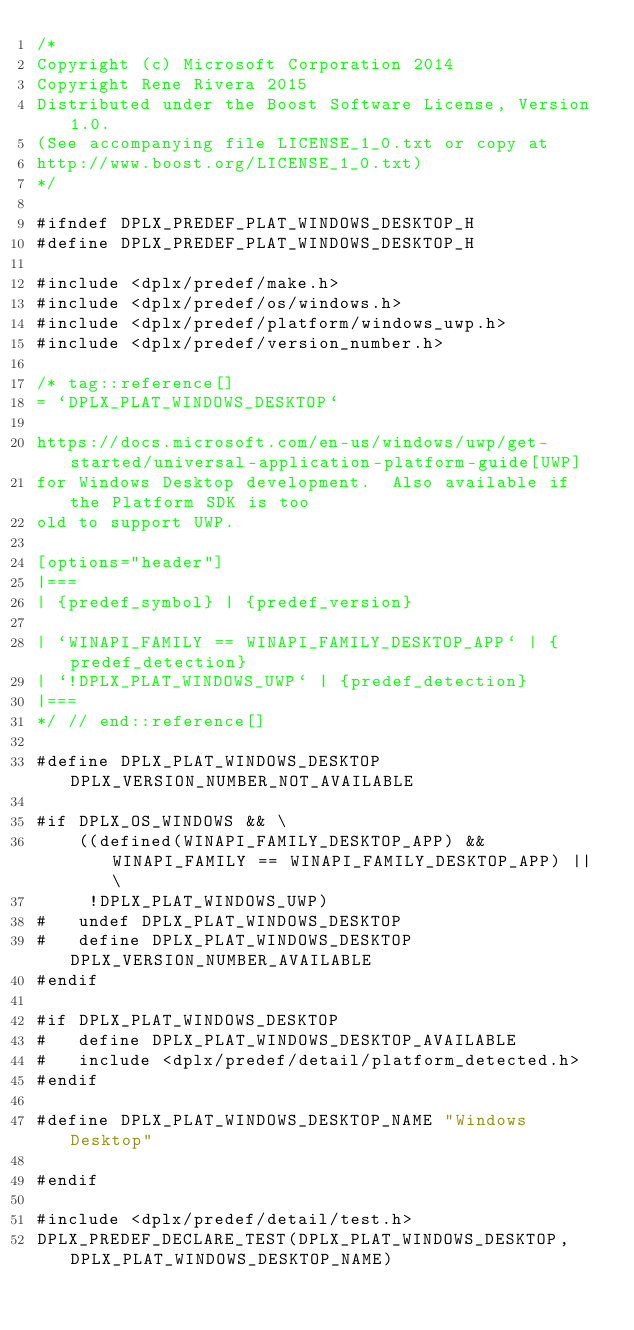<code> <loc_0><loc_0><loc_500><loc_500><_C_>/*
Copyright (c) Microsoft Corporation 2014
Copyright Rene Rivera 2015
Distributed under the Boost Software License, Version 1.0.
(See accompanying file LICENSE_1_0.txt or copy at
http://www.boost.org/LICENSE_1_0.txt)
*/

#ifndef DPLX_PREDEF_PLAT_WINDOWS_DESKTOP_H
#define DPLX_PREDEF_PLAT_WINDOWS_DESKTOP_H

#include <dplx/predef/make.h>
#include <dplx/predef/os/windows.h>
#include <dplx/predef/platform/windows_uwp.h>
#include <dplx/predef/version_number.h>

/* tag::reference[]
= `DPLX_PLAT_WINDOWS_DESKTOP`

https://docs.microsoft.com/en-us/windows/uwp/get-started/universal-application-platform-guide[UWP]
for Windows Desktop development.  Also available if the Platform SDK is too
old to support UWP.

[options="header"]
|===
| {predef_symbol} | {predef_version}

| `WINAPI_FAMILY == WINAPI_FAMILY_DESKTOP_APP` | {predef_detection}
| `!DPLX_PLAT_WINDOWS_UWP` | {predef_detection}
|===
*/ // end::reference[]

#define DPLX_PLAT_WINDOWS_DESKTOP DPLX_VERSION_NUMBER_NOT_AVAILABLE

#if DPLX_OS_WINDOWS && \
    ((defined(WINAPI_FAMILY_DESKTOP_APP) && WINAPI_FAMILY == WINAPI_FAMILY_DESKTOP_APP) || \
     !DPLX_PLAT_WINDOWS_UWP)
#   undef DPLX_PLAT_WINDOWS_DESKTOP
#   define DPLX_PLAT_WINDOWS_DESKTOP DPLX_VERSION_NUMBER_AVAILABLE
#endif
 
#if DPLX_PLAT_WINDOWS_DESKTOP
#   define DPLX_PLAT_WINDOWS_DESKTOP_AVAILABLE
#   include <dplx/predef/detail/platform_detected.h>
#endif

#define DPLX_PLAT_WINDOWS_DESKTOP_NAME "Windows Desktop"

#endif

#include <dplx/predef/detail/test.h>
DPLX_PREDEF_DECLARE_TEST(DPLX_PLAT_WINDOWS_DESKTOP,DPLX_PLAT_WINDOWS_DESKTOP_NAME)
</code> 